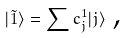Convert formula to latex. <formula><loc_0><loc_0><loc_500><loc_500>| \tilde { 1 } \rangle = \sum c _ { j } ^ { 1 } | j \rangle \text { ,}</formula> 